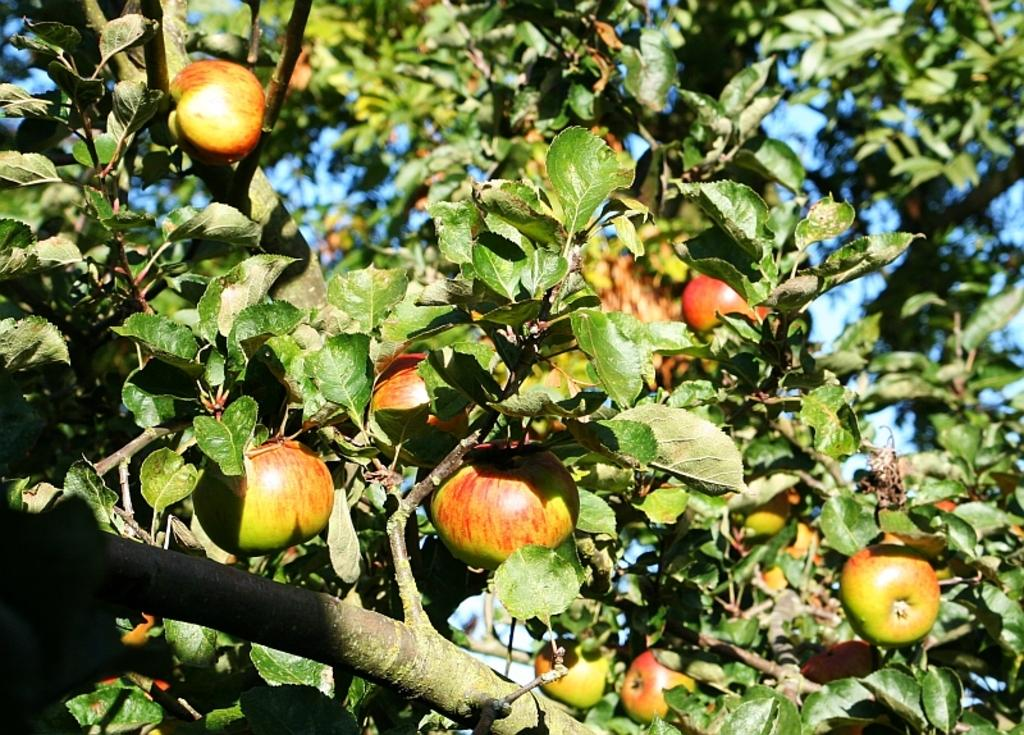What type of tree is depicted in the image? The image appears to be an apple tree. What can be seen hanging from the tree? There are apples hanging from the tree. What else is present on the tree besides apples? There are leaves and branches on the tree. Can you hear the owl talking to the apples in the image? There is no owl or talking in the image; it features an apple tree with apples, leaves, and branches. 